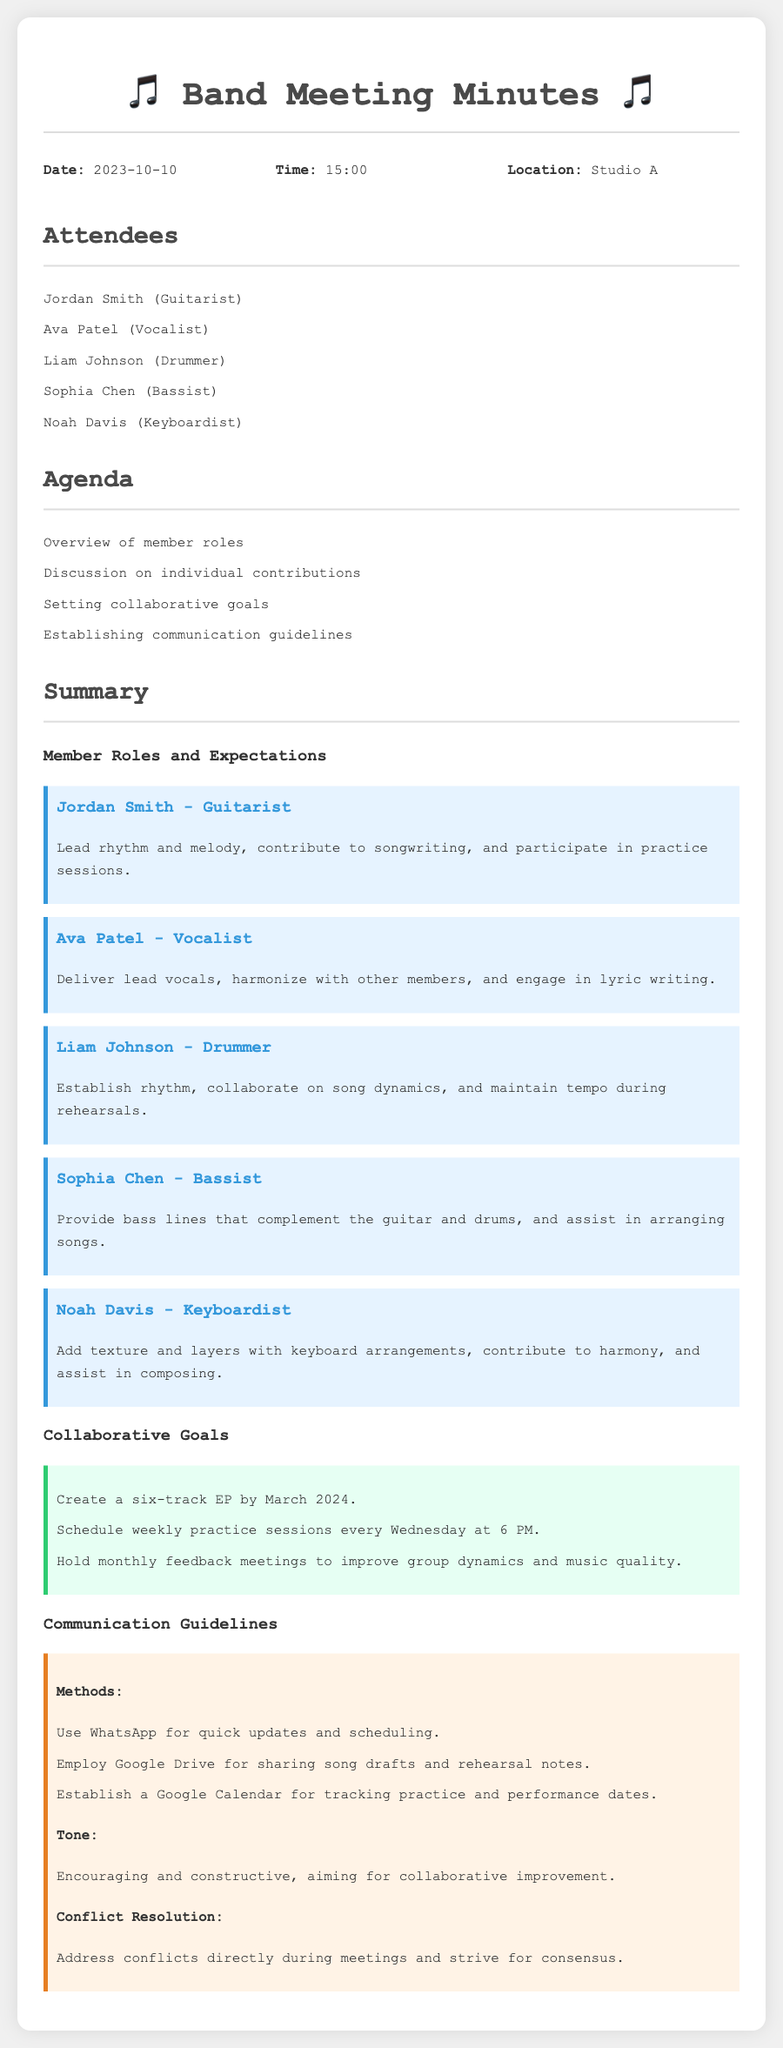What is the date of the meeting? The date is listed under the header "Date" in the document.
Answer: 2023-10-10 Who is the drummer? The drummer's name is mentioned in the "Attendees" section.
Answer: Liam Johnson How many tracks is the band planning for the EP? The number of tracks is specified in the "Collaborative Goals" section.
Answer: six What platform is used for sharing song drafts? The document mentions the specific platform under "Communication Guidelines".
Answer: Google Drive What is the time for the weekly practice sessions? The time for practice sessions is indicated in the "Collaborative Goals" section.
Answer: 6 PM Who is responsible for delivering lead vocals? The individual responsible for lead vocals is stated under "Member Roles and Expectations".
Answer: Ava Patel How often will feedback meetings be held? The frequency of feedback meetings is listed in the "Collaborative Goals".
Answer: monthly What is the tone expected during communication? The expected tone is outlined in the "Communication Guidelines" section.
Answer: Encouraging and constructive What is the location of the meeting? The location is specified under the header "Location".
Answer: Studio A 